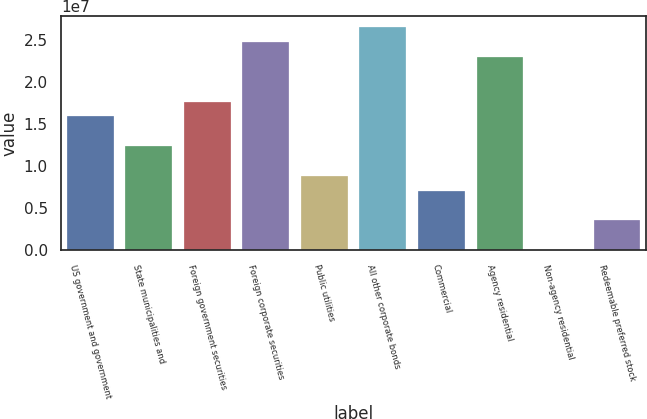<chart> <loc_0><loc_0><loc_500><loc_500><bar_chart><fcel>US government and government<fcel>State municipalities and<fcel>Foreign government securities<fcel>Foreign corporate securities<fcel>Public utilities<fcel>All other corporate bonds<fcel>Commercial<fcel>Agency residential<fcel>Non-agency residential<fcel>Redeemable preferred stock<nl><fcel>1.5905e+07<fcel>1.23708e+07<fcel>1.76722e+07<fcel>2.47407e+07<fcel>8.83654e+06<fcel>2.65078e+07<fcel>7.06941e+06<fcel>2.29736e+07<fcel>898<fcel>3.53515e+06<nl></chart> 